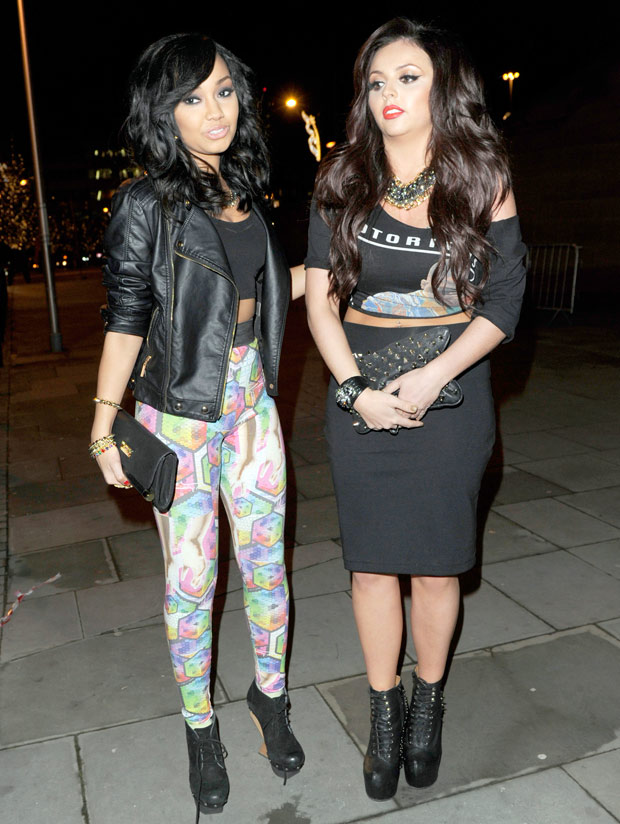What events do you think they might be attending? Given their stylish and coordinated attire, they might be attending a social event such as a nightclub party, a fashion event, or even a casual red carpet occasion. The nighttime setting and their glamorous outfits suggest an event where making a fashion statement would be appropriate. What else can we infer about the location based on their outfits? Considering their outfits, which are trendy and bold, with elements like a leather jacket and colorful leggings, it seems they're in a fashionable and vibrant urban area. This might be a part of the city known for its dynamic nightlife and fashion-forward crowd. The location likely supports vibrant social scenes, possibly near high-end clubs, bars, or entertainment districts. Tell me a short and a long realistic scenario of their evening. Short Scenario: They might be heading to a trendy new nightclub opening in the city, excited to dance and socialize with friends. Long Scenario: The evening starts with them meeting at a chic downtown bar for cocktails and appetizers. They share laughs and take photos, capturing their stylish outfits in the ambient, dimly lit setting. As the night progresses, they move to a popular nightclub known for its vibrant music and energetic crowd. They dance till late, enjoying the DJ's set and mingling with other fashion-forward individuals. It's a memorable night filled with laughter, great music, and the electric buzz of the city's nightlife. On their way back, they might stop for a quick bite at a late-night food truck, reminiscing about the night's highlights before heading home. 